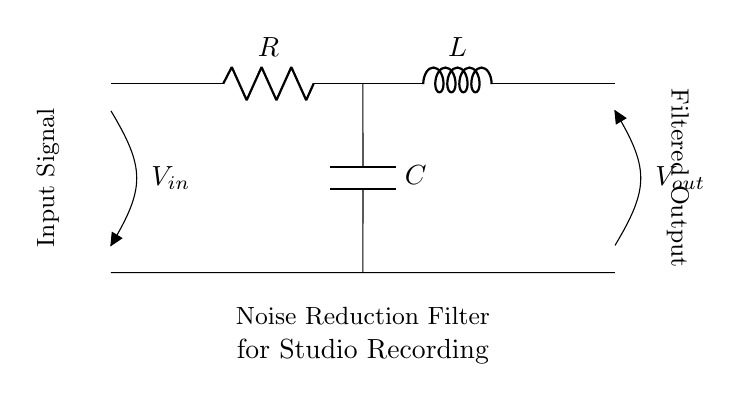What components are in this circuit? The circuit contains a resistor, an inductor, and a capacitor, which are the key RLC components in the noise reduction filter.
Answer: Resistor, inductor, capacitor What does V in represent? The V in represents the input signal voltage to the noise reduction filter, indicating where the signal enters the circuit.
Answer: Input signal What happens at V out? V out represents the filtered output voltage, showing the result after the signal has passed through the RLC components.
Answer: Filtered output What is the function of the capacitor? The capacitor serves to block DC components of the input signal while allowing AC signals to pass, which is important in noise reduction applications.
Answer: Block DC How does the inductor affect frequency response? The inductor tends to impede high-frequency signals while allowing low-frequency signals to pass, contributing to the filter's ability to reduce noise at certain frequencies.
Answer: Impedes high frequency What is the overall purpose of this RLC circuit? The overall purpose is to create a noise reduction filter that cleans up the input signal for clearer audio during studio recordings by modulating frequency response.
Answer: Noise reduction filter What type of filter does this circuit represent? This circuit represents a band-pass filter configuration, as it is designed to only allow certain frequency ranges to pass while attenuating others, crucial for noise reduction.
Answer: Band-pass filter 